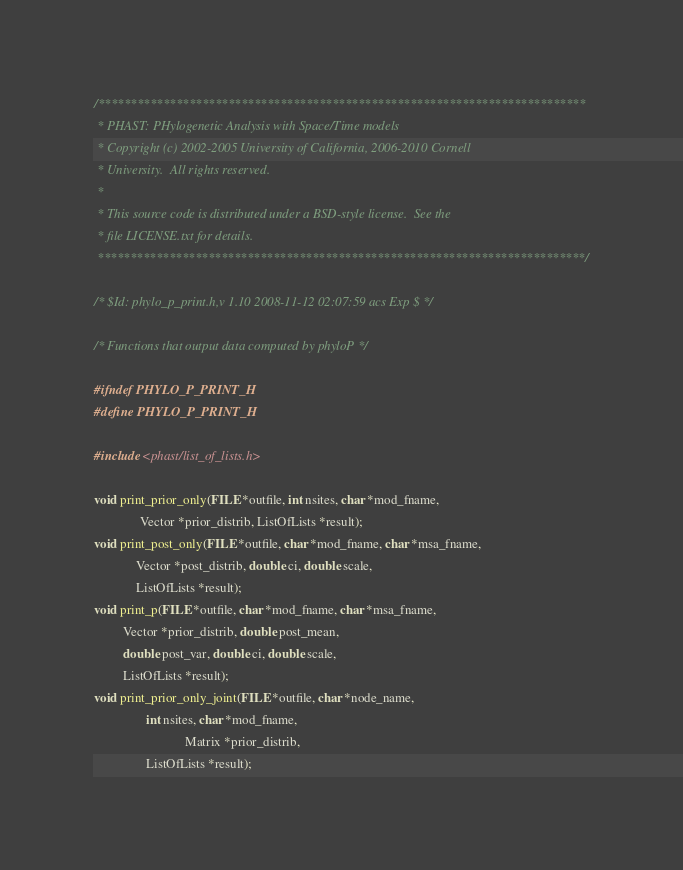<code> <loc_0><loc_0><loc_500><loc_500><_C_>/***************************************************************************
 * PHAST: PHylogenetic Analysis with Space/Time models
 * Copyright (c) 2002-2005 University of California, 2006-2010 Cornell 
 * University.  All rights reserved.
 *
 * This source code is distributed under a BSD-style license.  See the
 * file LICENSE.txt for details.
 ***************************************************************************/

/* $Id: phylo_p_print.h,v 1.10 2008-11-12 02:07:59 acs Exp $ */

/* Functions that output data computed by phyloP */

#ifndef PHYLO_P_PRINT_H
#define PHYLO_P_PRINT_H

#include <phast/list_of_lists.h>

void print_prior_only(FILE *outfile, int nsites, char *mod_fname, 
		      Vector *prior_distrib, ListOfLists *result);
void print_post_only(FILE *outfile, char *mod_fname, char *msa_fname, 
		     Vector *post_distrib, double ci, double scale,
		     ListOfLists *result);
void print_p(FILE *outfile, char *mod_fname, char *msa_fname, 
	     Vector *prior_distrib, double post_mean, 
	     double post_var, double ci, double scale,
	     ListOfLists *result);
void print_prior_only_joint(FILE *outfile, char *node_name, 
			    int nsites, char *mod_fname, 
                            Matrix *prior_distrib,
			    ListOfLists *result);</code> 